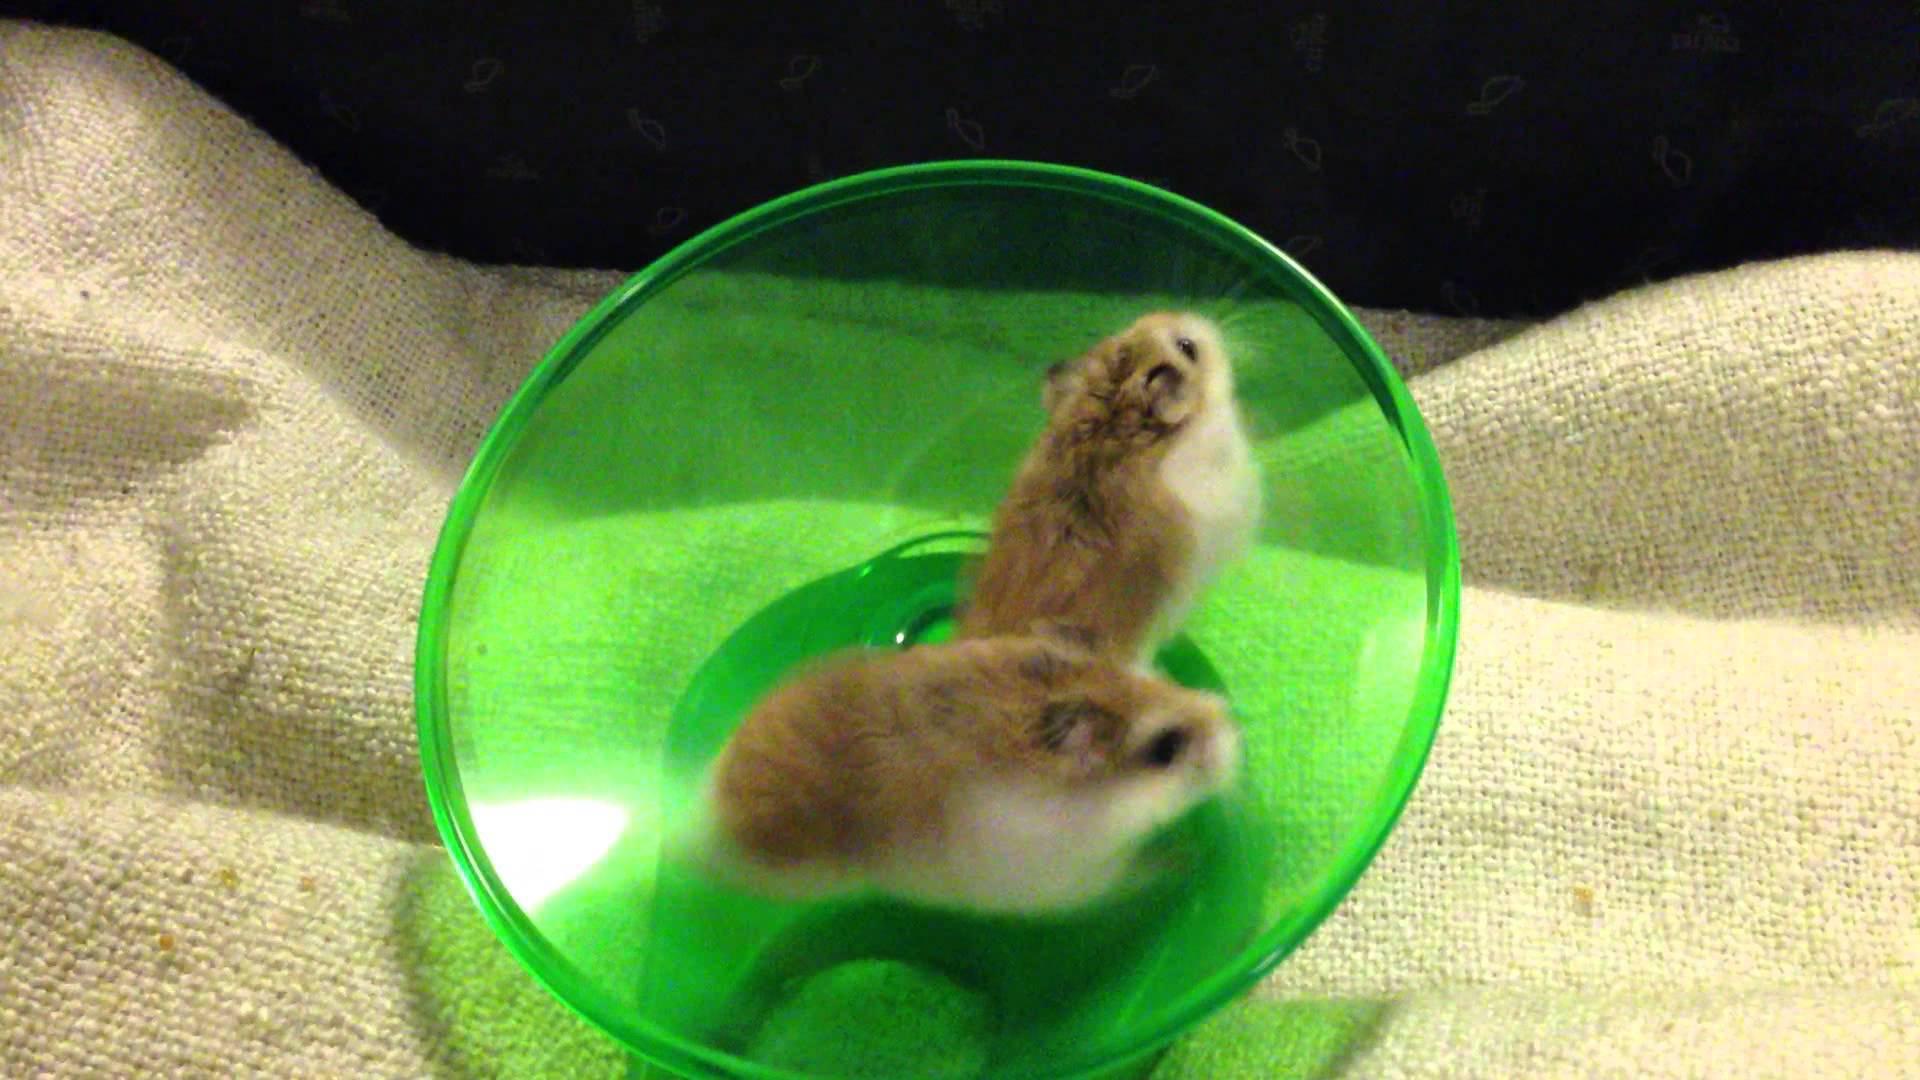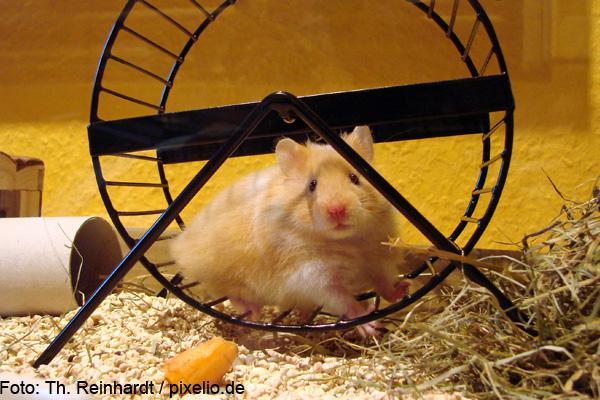The first image is the image on the left, the second image is the image on the right. Examine the images to the left and right. Is the description "the right image has a hamster in a wheel made of blue metal" accurate? Answer yes or no. No. 